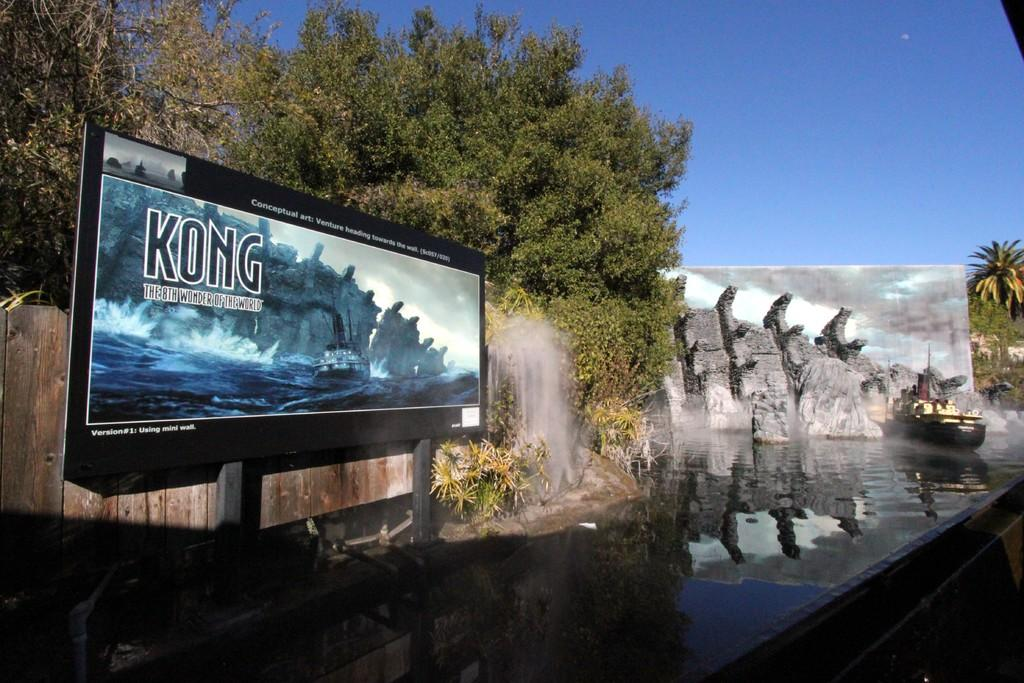<image>
Present a compact description of the photo's key features. A boat going along a river with a Kong adboard by the waterfall. 